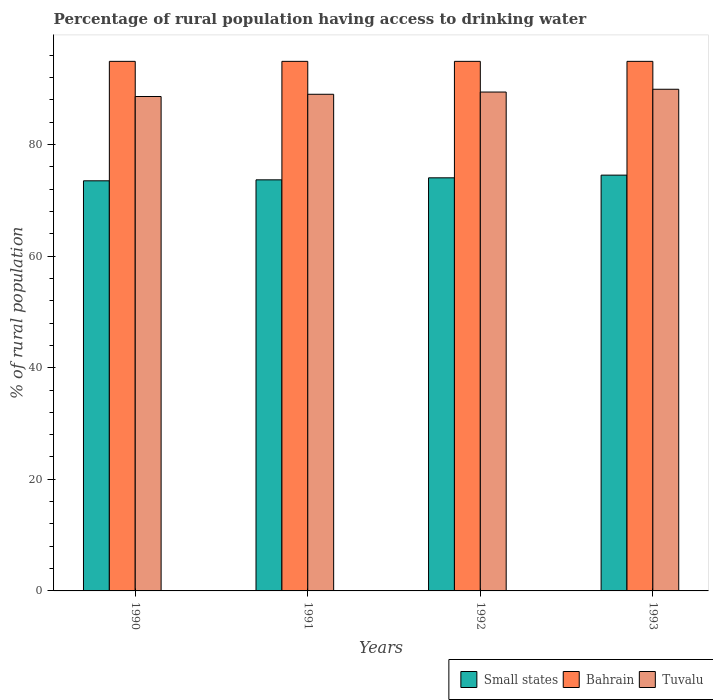How many different coloured bars are there?
Your response must be concise. 3. How many groups of bars are there?
Your answer should be very brief. 4. Are the number of bars per tick equal to the number of legend labels?
Ensure brevity in your answer.  Yes. How many bars are there on the 3rd tick from the right?
Keep it short and to the point. 3. What is the label of the 3rd group of bars from the left?
Your response must be concise. 1992. What is the percentage of rural population having access to drinking water in Tuvalu in 1990?
Make the answer very short. 88.6. Across all years, what is the maximum percentage of rural population having access to drinking water in Small states?
Your answer should be compact. 74.51. Across all years, what is the minimum percentage of rural population having access to drinking water in Bahrain?
Provide a succinct answer. 94.9. What is the total percentage of rural population having access to drinking water in Small states in the graph?
Give a very brief answer. 295.7. What is the difference between the percentage of rural population having access to drinking water in Tuvalu in 1993 and the percentage of rural population having access to drinking water in Small states in 1990?
Offer a very short reply. 16.41. What is the average percentage of rural population having access to drinking water in Tuvalu per year?
Give a very brief answer. 89.22. In the year 1991, what is the difference between the percentage of rural population having access to drinking water in Small states and percentage of rural population having access to drinking water in Tuvalu?
Offer a very short reply. -15.33. What is the ratio of the percentage of rural population having access to drinking water in Tuvalu in 1990 to that in 1993?
Offer a very short reply. 0.99. Is the percentage of rural population having access to drinking water in Bahrain in 1990 less than that in 1993?
Make the answer very short. No. Is the difference between the percentage of rural population having access to drinking water in Small states in 1990 and 1992 greater than the difference between the percentage of rural population having access to drinking water in Tuvalu in 1990 and 1992?
Provide a short and direct response. Yes. What is the difference between the highest and the second highest percentage of rural population having access to drinking water in Small states?
Your answer should be very brief. 0.48. What is the difference between the highest and the lowest percentage of rural population having access to drinking water in Small states?
Offer a terse response. 1.02. Is the sum of the percentage of rural population having access to drinking water in Small states in 1990 and 1991 greater than the maximum percentage of rural population having access to drinking water in Tuvalu across all years?
Keep it short and to the point. Yes. What does the 1st bar from the left in 1990 represents?
Your response must be concise. Small states. What does the 1st bar from the right in 1992 represents?
Offer a terse response. Tuvalu. Is it the case that in every year, the sum of the percentage of rural population having access to drinking water in Bahrain and percentage of rural population having access to drinking water in Tuvalu is greater than the percentage of rural population having access to drinking water in Small states?
Provide a succinct answer. Yes. How many bars are there?
Give a very brief answer. 12. What is the difference between two consecutive major ticks on the Y-axis?
Provide a short and direct response. 20. Does the graph contain any zero values?
Give a very brief answer. No. Does the graph contain grids?
Offer a very short reply. No. How many legend labels are there?
Your answer should be compact. 3. How are the legend labels stacked?
Give a very brief answer. Horizontal. What is the title of the graph?
Keep it short and to the point. Percentage of rural population having access to drinking water. Does "Malaysia" appear as one of the legend labels in the graph?
Your response must be concise. No. What is the label or title of the Y-axis?
Provide a short and direct response. % of rural population. What is the % of rural population in Small states in 1990?
Offer a very short reply. 73.49. What is the % of rural population of Bahrain in 1990?
Offer a very short reply. 94.9. What is the % of rural population in Tuvalu in 1990?
Make the answer very short. 88.6. What is the % of rural population of Small states in 1991?
Keep it short and to the point. 73.67. What is the % of rural population of Bahrain in 1991?
Provide a short and direct response. 94.9. What is the % of rural population of Tuvalu in 1991?
Provide a succinct answer. 89. What is the % of rural population of Small states in 1992?
Give a very brief answer. 74.03. What is the % of rural population in Bahrain in 1992?
Provide a short and direct response. 94.9. What is the % of rural population in Tuvalu in 1992?
Your response must be concise. 89.4. What is the % of rural population of Small states in 1993?
Keep it short and to the point. 74.51. What is the % of rural population in Bahrain in 1993?
Offer a terse response. 94.9. What is the % of rural population of Tuvalu in 1993?
Provide a short and direct response. 89.9. Across all years, what is the maximum % of rural population of Small states?
Provide a succinct answer. 74.51. Across all years, what is the maximum % of rural population of Bahrain?
Ensure brevity in your answer.  94.9. Across all years, what is the maximum % of rural population in Tuvalu?
Keep it short and to the point. 89.9. Across all years, what is the minimum % of rural population of Small states?
Give a very brief answer. 73.49. Across all years, what is the minimum % of rural population in Bahrain?
Your answer should be very brief. 94.9. Across all years, what is the minimum % of rural population in Tuvalu?
Make the answer very short. 88.6. What is the total % of rural population of Small states in the graph?
Keep it short and to the point. 295.7. What is the total % of rural population of Bahrain in the graph?
Provide a short and direct response. 379.6. What is the total % of rural population in Tuvalu in the graph?
Ensure brevity in your answer.  356.9. What is the difference between the % of rural population of Small states in 1990 and that in 1991?
Your answer should be compact. -0.17. What is the difference between the % of rural population of Small states in 1990 and that in 1992?
Ensure brevity in your answer.  -0.53. What is the difference between the % of rural population of Bahrain in 1990 and that in 1992?
Provide a short and direct response. 0. What is the difference between the % of rural population of Small states in 1990 and that in 1993?
Give a very brief answer. -1.02. What is the difference between the % of rural population of Small states in 1991 and that in 1992?
Provide a short and direct response. -0.36. What is the difference between the % of rural population of Tuvalu in 1991 and that in 1992?
Your response must be concise. -0.4. What is the difference between the % of rural population in Small states in 1991 and that in 1993?
Offer a terse response. -0.84. What is the difference between the % of rural population of Small states in 1992 and that in 1993?
Offer a very short reply. -0.48. What is the difference between the % of rural population of Bahrain in 1992 and that in 1993?
Your answer should be compact. 0. What is the difference between the % of rural population of Tuvalu in 1992 and that in 1993?
Provide a short and direct response. -0.5. What is the difference between the % of rural population of Small states in 1990 and the % of rural population of Bahrain in 1991?
Your response must be concise. -21.41. What is the difference between the % of rural population of Small states in 1990 and the % of rural population of Tuvalu in 1991?
Provide a short and direct response. -15.51. What is the difference between the % of rural population of Bahrain in 1990 and the % of rural population of Tuvalu in 1991?
Make the answer very short. 5.9. What is the difference between the % of rural population of Small states in 1990 and the % of rural population of Bahrain in 1992?
Offer a very short reply. -21.41. What is the difference between the % of rural population of Small states in 1990 and the % of rural population of Tuvalu in 1992?
Ensure brevity in your answer.  -15.91. What is the difference between the % of rural population in Small states in 1990 and the % of rural population in Bahrain in 1993?
Offer a terse response. -21.41. What is the difference between the % of rural population of Small states in 1990 and the % of rural population of Tuvalu in 1993?
Give a very brief answer. -16.41. What is the difference between the % of rural population in Small states in 1991 and the % of rural population in Bahrain in 1992?
Give a very brief answer. -21.23. What is the difference between the % of rural population of Small states in 1991 and the % of rural population of Tuvalu in 1992?
Your response must be concise. -15.73. What is the difference between the % of rural population of Small states in 1991 and the % of rural population of Bahrain in 1993?
Make the answer very short. -21.23. What is the difference between the % of rural population in Small states in 1991 and the % of rural population in Tuvalu in 1993?
Provide a succinct answer. -16.23. What is the difference between the % of rural population in Bahrain in 1991 and the % of rural population in Tuvalu in 1993?
Make the answer very short. 5. What is the difference between the % of rural population in Small states in 1992 and the % of rural population in Bahrain in 1993?
Your answer should be compact. -20.87. What is the difference between the % of rural population of Small states in 1992 and the % of rural population of Tuvalu in 1993?
Provide a succinct answer. -15.87. What is the average % of rural population in Small states per year?
Provide a succinct answer. 73.93. What is the average % of rural population in Bahrain per year?
Provide a succinct answer. 94.9. What is the average % of rural population in Tuvalu per year?
Provide a short and direct response. 89.22. In the year 1990, what is the difference between the % of rural population in Small states and % of rural population in Bahrain?
Keep it short and to the point. -21.41. In the year 1990, what is the difference between the % of rural population in Small states and % of rural population in Tuvalu?
Your answer should be compact. -15.11. In the year 1990, what is the difference between the % of rural population in Bahrain and % of rural population in Tuvalu?
Offer a terse response. 6.3. In the year 1991, what is the difference between the % of rural population in Small states and % of rural population in Bahrain?
Make the answer very short. -21.23. In the year 1991, what is the difference between the % of rural population of Small states and % of rural population of Tuvalu?
Ensure brevity in your answer.  -15.33. In the year 1991, what is the difference between the % of rural population in Bahrain and % of rural population in Tuvalu?
Ensure brevity in your answer.  5.9. In the year 1992, what is the difference between the % of rural population of Small states and % of rural population of Bahrain?
Make the answer very short. -20.87. In the year 1992, what is the difference between the % of rural population of Small states and % of rural population of Tuvalu?
Keep it short and to the point. -15.37. In the year 1993, what is the difference between the % of rural population in Small states and % of rural population in Bahrain?
Your answer should be compact. -20.39. In the year 1993, what is the difference between the % of rural population of Small states and % of rural population of Tuvalu?
Your answer should be very brief. -15.39. What is the ratio of the % of rural population in Small states in 1990 to that in 1991?
Your response must be concise. 1. What is the ratio of the % of rural population in Tuvalu in 1990 to that in 1991?
Your answer should be compact. 1. What is the ratio of the % of rural population of Small states in 1990 to that in 1992?
Provide a succinct answer. 0.99. What is the ratio of the % of rural population in Bahrain in 1990 to that in 1992?
Your answer should be very brief. 1. What is the ratio of the % of rural population of Tuvalu in 1990 to that in 1992?
Give a very brief answer. 0.99. What is the ratio of the % of rural population of Small states in 1990 to that in 1993?
Provide a succinct answer. 0.99. What is the ratio of the % of rural population in Bahrain in 1990 to that in 1993?
Provide a short and direct response. 1. What is the ratio of the % of rural population in Tuvalu in 1990 to that in 1993?
Provide a short and direct response. 0.99. What is the ratio of the % of rural population in Small states in 1991 to that in 1992?
Provide a succinct answer. 1. What is the ratio of the % of rural population in Tuvalu in 1991 to that in 1992?
Offer a terse response. 1. What is the ratio of the % of rural population of Small states in 1991 to that in 1993?
Provide a succinct answer. 0.99. What is the ratio of the % of rural population in Bahrain in 1991 to that in 1993?
Your answer should be very brief. 1. What is the ratio of the % of rural population of Tuvalu in 1991 to that in 1993?
Keep it short and to the point. 0.99. What is the ratio of the % of rural population in Small states in 1992 to that in 1993?
Offer a terse response. 0.99. What is the ratio of the % of rural population in Bahrain in 1992 to that in 1993?
Provide a succinct answer. 1. What is the difference between the highest and the second highest % of rural population of Small states?
Offer a very short reply. 0.48. What is the difference between the highest and the second highest % of rural population in Bahrain?
Your answer should be very brief. 0. What is the difference between the highest and the lowest % of rural population of Small states?
Ensure brevity in your answer.  1.02. What is the difference between the highest and the lowest % of rural population of Tuvalu?
Your answer should be very brief. 1.3. 